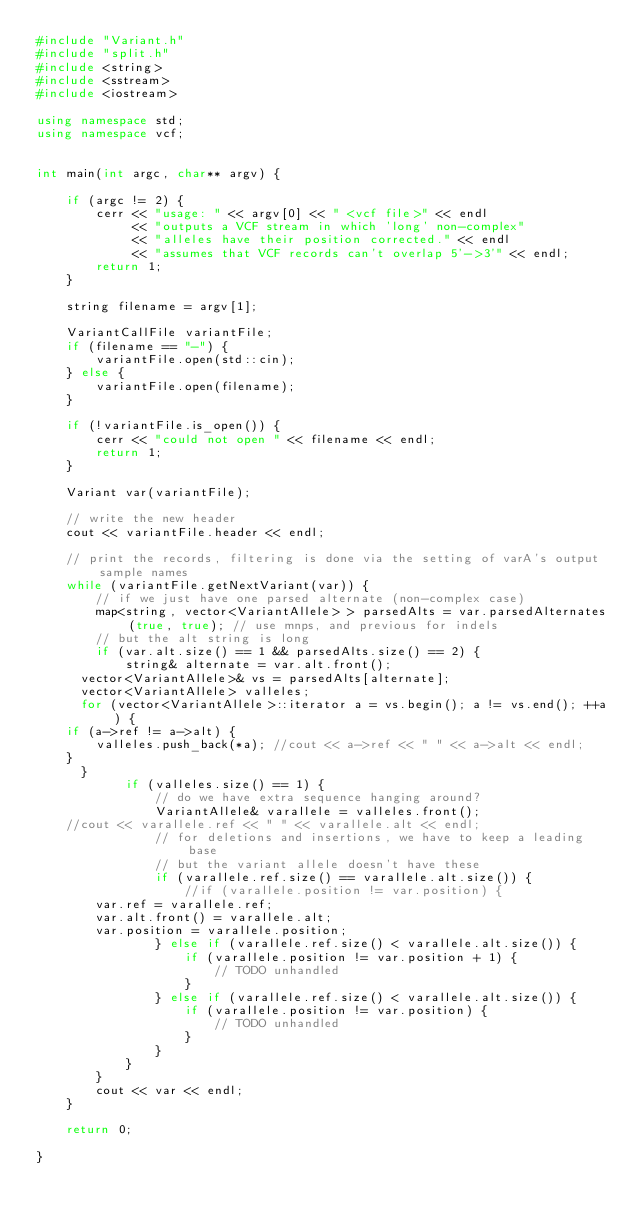<code> <loc_0><loc_0><loc_500><loc_500><_C++_>#include "Variant.h"
#include "split.h"
#include <string>
#include <sstream>
#include <iostream>

using namespace std;
using namespace vcf;


int main(int argc, char** argv) {

    if (argc != 2) {
        cerr << "usage: " << argv[0] << " <vcf file>" << endl
             << "outputs a VCF stream in which 'long' non-complex"
             << "alleles have their position corrected." << endl
             << "assumes that VCF records can't overlap 5'->3'" << endl;
        return 1;
    }

    string filename = argv[1];

    VariantCallFile variantFile;
    if (filename == "-") {
        variantFile.open(std::cin);
    } else {
        variantFile.open(filename);
    }

    if (!variantFile.is_open()) {
        cerr << "could not open " << filename << endl;
        return 1;
    }

    Variant var(variantFile);

    // write the new header
    cout << variantFile.header << endl;
 
    // print the records, filtering is done via the setting of varA's output sample names
    while (variantFile.getNextVariant(var)) {
        // if we just have one parsed alternate (non-complex case)
        map<string, vector<VariantAllele> > parsedAlts = var.parsedAlternates(true, true); // use mnps, and previous for indels
        // but the alt string is long
        if (var.alt.size() == 1 && parsedAlts.size() == 2) {
            string& alternate = var.alt.front();
	    vector<VariantAllele>& vs = parsedAlts[alternate];
	    vector<VariantAllele> valleles;
	    for (vector<VariantAllele>::iterator a = vs.begin(); a != vs.end(); ++a) {
		if (a->ref != a->alt) {
		    valleles.push_back(*a); //cout << a->ref << " " << a->alt << endl;
		}
	    }
            if (valleles.size() == 1) {
                // do we have extra sequence hanging around?
                VariantAllele& varallele = valleles.front();
		//cout << varallele.ref << " " << varallele.alt << endl;
                // for deletions and insertions, we have to keep a leading base
                // but the variant allele doesn't have these
                if (varallele.ref.size() == varallele.alt.size()) {
                    //if (varallele.position != var.position) {
		    var.ref = varallele.ref;
		    var.alt.front() = varallele.alt;
		    var.position = varallele.position;
                } else if (varallele.ref.size() < varallele.alt.size()) {
                    if (varallele.position != var.position + 1) {
                        // TODO unhandled
                    }
                } else if (varallele.ref.size() < varallele.alt.size()) {
                    if (varallele.position != var.position) {
                        // TODO unhandled
                    }
                }
            }
        }
        cout << var << endl;
    }

    return 0;

}

</code> 